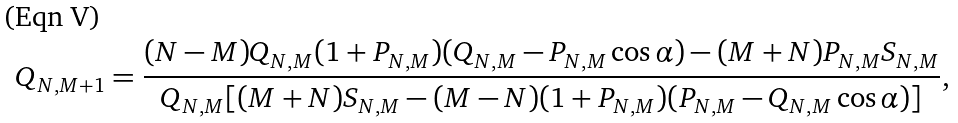<formula> <loc_0><loc_0><loc_500><loc_500>Q _ { N , M + 1 } = \frac { ( N - M ) Q _ { N , M } ( 1 + P _ { N , M } ) ( Q _ { N , M } - P _ { N , M } \cos \alpha ) - ( M + N ) P _ { N , M } S _ { N , M } } { Q _ { N , M } [ ( M + N ) S _ { N , M } - ( M - N ) ( 1 + P _ { N , M } ) ( P _ { N , M } - Q _ { N , M } \cos \alpha ) ] } ,</formula> 